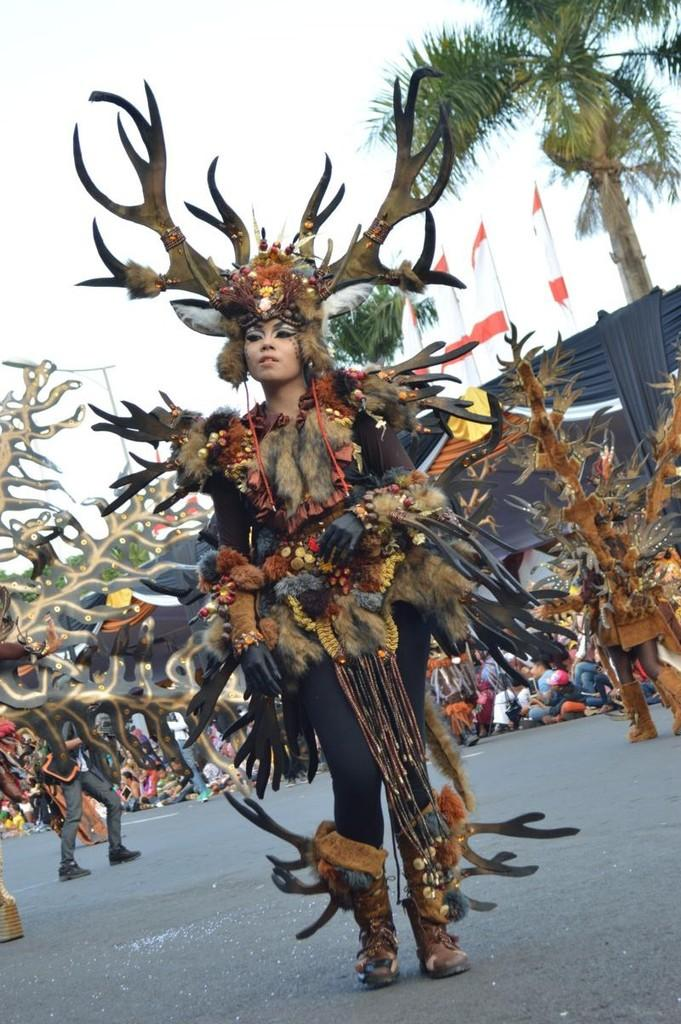What are the persons in the image doing? The persons in the image are performing while wearing costumes. Where is the performance taking place? The performance is taking place on the road. What can be seen in the background of the image? There is a tree and a building in the background of the image, as well as a group of persons. What type of silver wound is visible on the person's costume in the image? There is no silver wound visible on any person's costume in the image. How does the anger of the performers affect their performance in the image? There is no indication of anger or any emotional state of the performers in the image. 